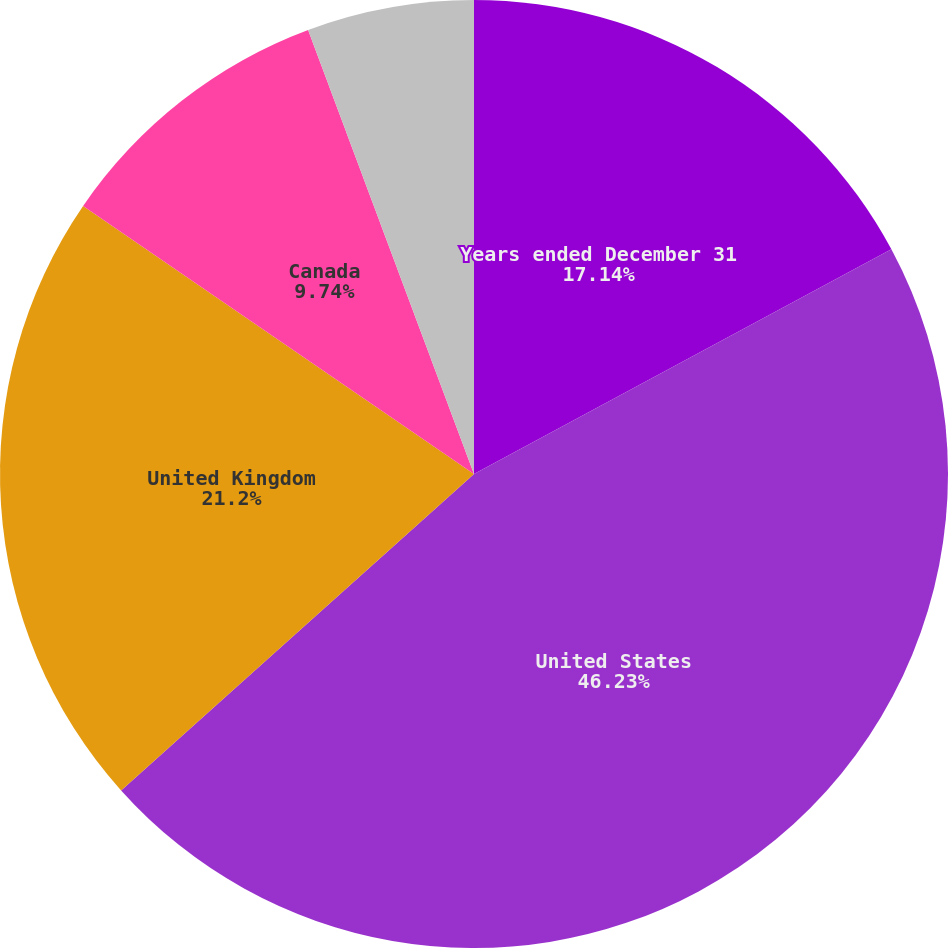Convert chart to OTSL. <chart><loc_0><loc_0><loc_500><loc_500><pie_chart><fcel>Years ended December 31<fcel>United States<fcel>United Kingdom<fcel>Canada<fcel>Other net of eliminations<nl><fcel>17.14%<fcel>46.22%<fcel>21.2%<fcel>9.74%<fcel>5.69%<nl></chart> 